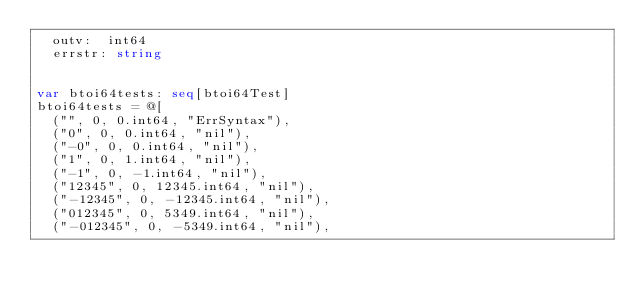<code> <loc_0><loc_0><loc_500><loc_500><_Nim_>  outv:  int64
  errstr: string


var btoi64tests: seq[btoi64Test]
btoi64tests = @[
  ("", 0, 0.int64, "ErrSyntax"),
  ("0", 0, 0.int64, "nil"),
  ("-0", 0, 0.int64, "nil"),
  ("1", 0, 1.int64, "nil"),
  ("-1", 0, -1.int64, "nil"),
  ("12345", 0, 12345.int64, "nil"),
  ("-12345", 0, -12345.int64, "nil"),
  ("012345", 0, 5349.int64, "nil"),
  ("-012345", 0, -5349.int64, "nil"),</code> 